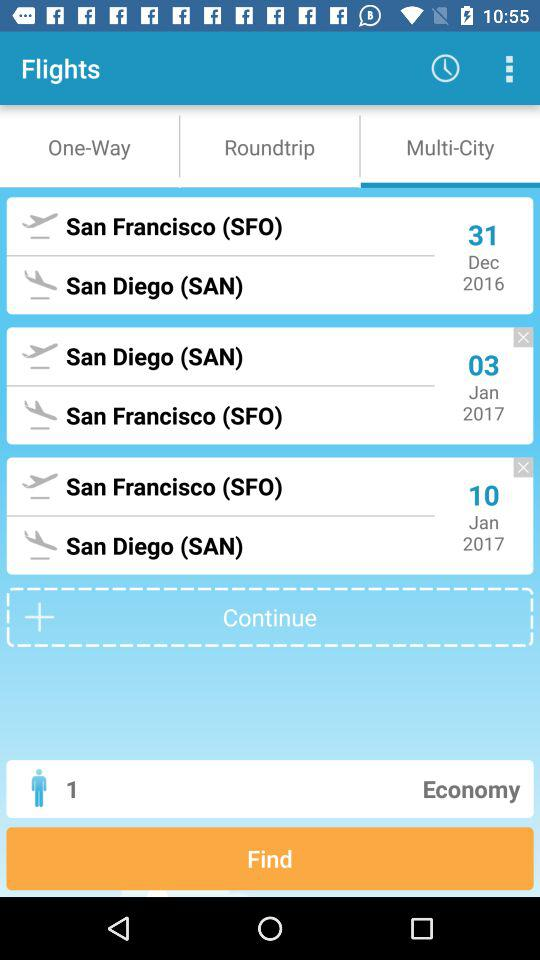What's the selected tab? The selected tab is "Multi-City". 